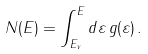Convert formula to latex. <formula><loc_0><loc_0><loc_500><loc_500>N ( E ) = \int _ { E _ { v } } ^ { E } d \varepsilon \, g ( \varepsilon ) \, .</formula> 